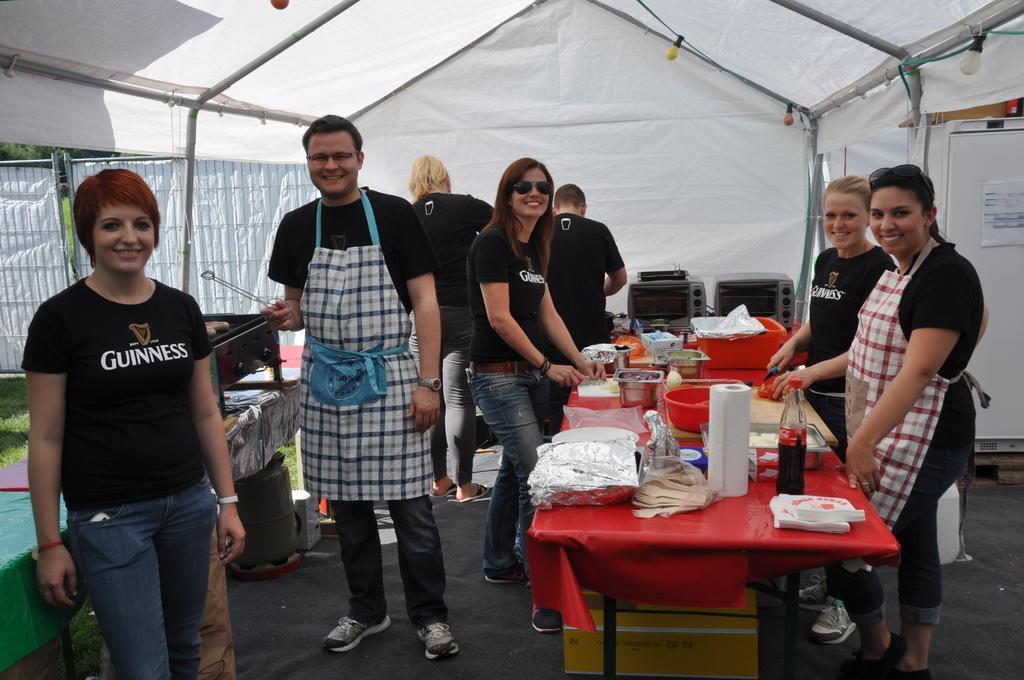Describe this image in one or two sentences. In the given image we can see that, there are seven people standing. There is a table on which red color cloth is kept on the table we can see a bottle, tissue and bowl. This is a trend, these are the lights. We can even see grass. 